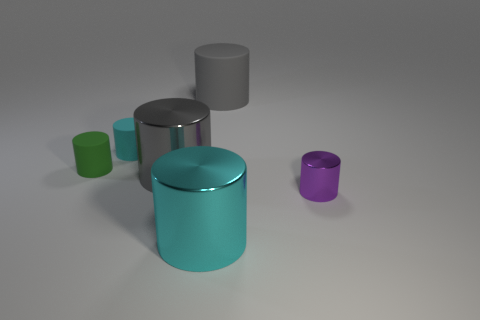What is the cyan cylinder in front of the tiny purple cylinder made of?
Ensure brevity in your answer.  Metal. There is a small metallic cylinder; is its color the same as the tiny matte cylinder that is behind the green thing?
Make the answer very short. No. What number of objects are tiny cylinders to the left of the large rubber cylinder or objects in front of the green cylinder?
Your answer should be compact. 5. What color is the big cylinder that is both behind the cyan shiny thing and in front of the green rubber cylinder?
Your response must be concise. Gray. Are there more blue spheres than shiny cylinders?
Provide a short and direct response. No. There is a gray object that is behind the small green object; does it have the same shape as the tiny green object?
Provide a short and direct response. Yes. How many matte things are either big cyan things or large yellow spheres?
Provide a short and direct response. 0. Is there a big thing that has the same material as the small purple object?
Your response must be concise. Yes. What is the material of the small cyan cylinder?
Provide a short and direct response. Rubber. The big metal thing that is right of the large metal object that is left of the shiny cylinder in front of the small purple thing is what shape?
Your answer should be compact. Cylinder. 